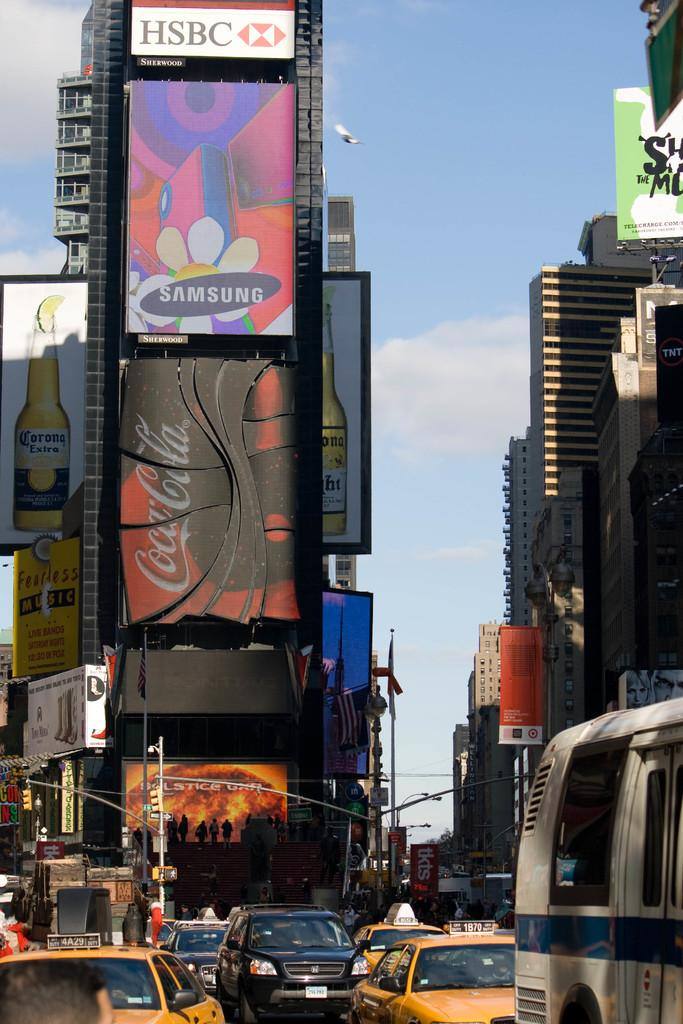<image>
Provide a brief description of the given image. crowded street and digital billboards for such companies as samsung and coca-cola 